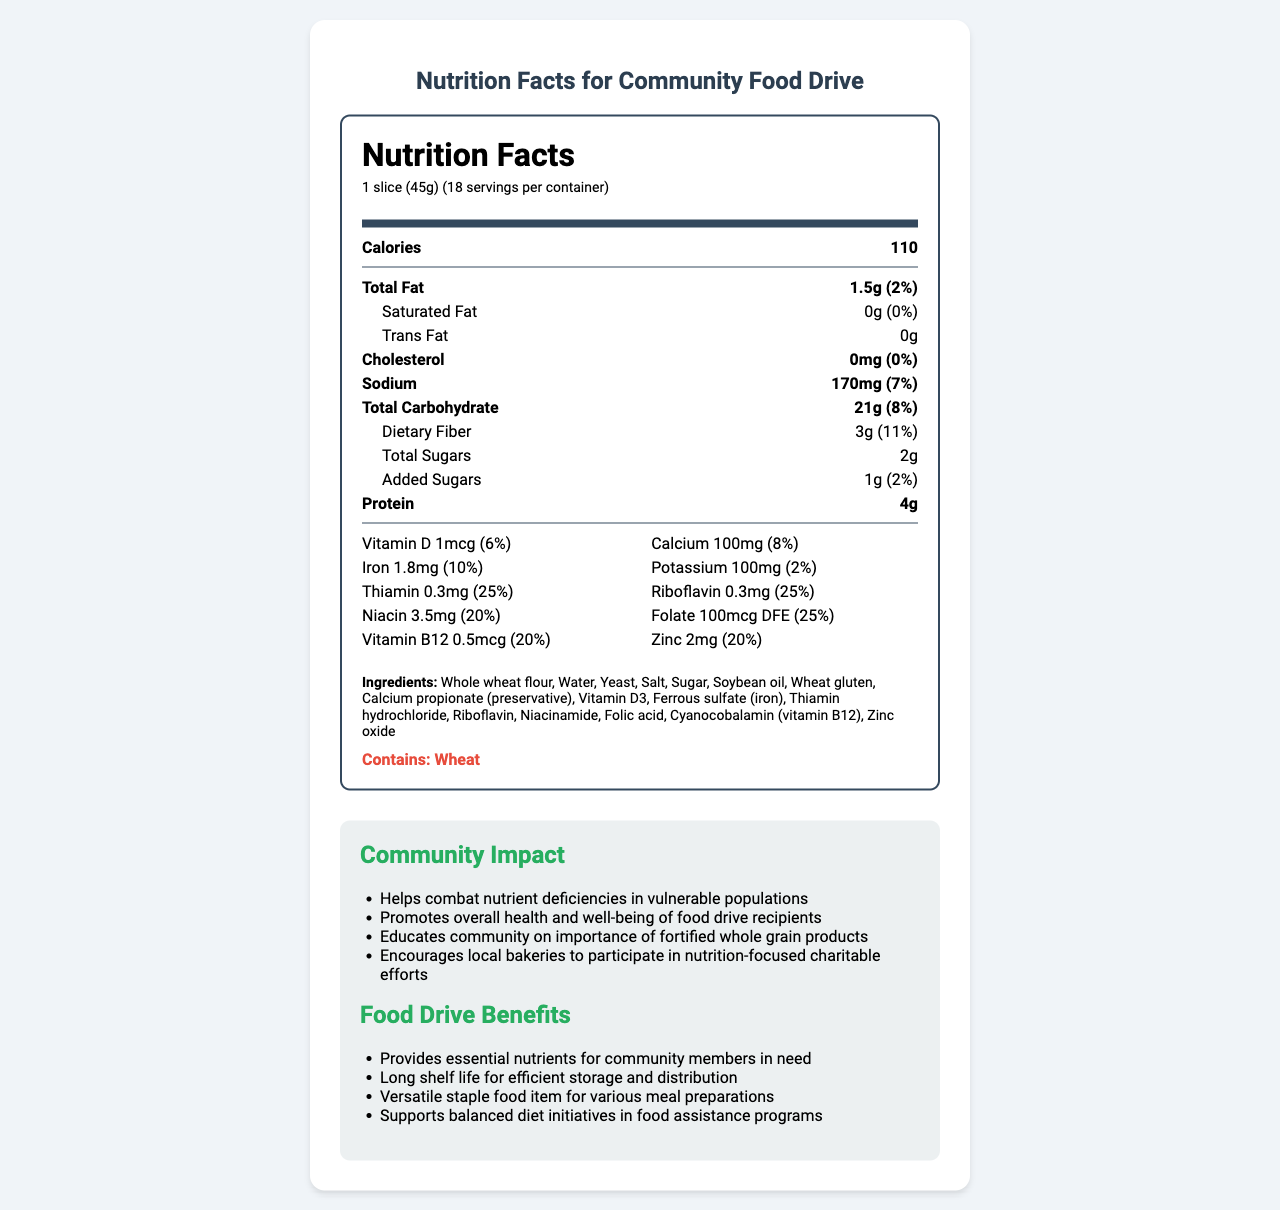what is the serving size? The serving size is listed as "1 slice (45g)".
Answer: 1 slice (45g) how many calories are there per serving? The calories per serving are specified as 110 calories.
Answer: 110 what is the total carbohydrate content per serving? The total carbohydrate content per serving is listed as 21g.
Answer: 21g how much iron is in one serving, and what percentage of the daily value does it represent? The iron content per serving is 1.8mg, which represents 10% of the daily value.
Answer: 1.8mg, 10% what vitamins are fortified in the bread, and what are their daily values? The vitamins fortified in the bread and their daily values are: Vitamin D (6%), Thiamin (25%), Riboflavin (25%), Niacin (20%), Folate (25%), Vitamin B12 (20%).
Answer: Vitamin D (6%), Thiamin (25%), Riboflavin (25%), Niacin (20%), Folate (25%), Vitamin B12 (20%) what are the allergens present in this bread? The allergen information states that the bread contains wheat.
Answer: Wheat which of the following nutrients does the bread provide 25% of the daily value? A. Vitamin D B. Vitamin B12 C. Thiamin D. Iron Thiamin provides 25% of the daily value, which is listed in the document.
Answer: C. Thiamin how many grams of dietary fiber are there per serving? The dietary fiber content per serving is listed as 3g.
Answer: 3g how much sodium does one slice contain, and what is its percentage of daily value? One slice contains 170mg of sodium, which represents 7% of the daily value.
Answer: 170mg, 7% is there any trans fat in this bread? The trans fat content is listed as 0g, indicating there is no trans fat in this bread.
Answer: No how does the bread benefit the community food drive? (choose all that apply) I. Provides essential nutrients for community members in need II. Long shelf life for efficient storage and distribution III. Versatile staple food item for various meal preparations IV. Contains no sugars V. Supports balanced diet initiatives in food assistance programs The benefits listed are: I. Provides essential nutrients for community members in need, II. Long shelf life for efficient storage and distribution, III. Versatile staple food item for various meal preparations, V. Supports balanced diet initiatives in food assistance programs.
Answer: I, II, III, V how many servings are there per container? The document states that there are 18 servings per container.
Answer: 18 what is the main idea of the document? The document is a comprehensive presentation of the nutritional aspects of Community Harvest Fortified Whole Grain Bread, its ingredients, and how it benefits the community, especially in a food drive context.
Answer: The document provides detailed nutritional information about Community Harvest Fortified Whole Grain Bread, emphasizing its vitamin and mineral content, ingredients, allergen information, and the benefits for the community food drive. does the bread contain calcium? The document lists that one serving contains 100mg of calcium, which is 8% of the daily value.
Answer: Yes what are the community impacts of distributing this bread through the food drive? The community impact section lists these specific benefits: Helps combat nutrient deficiencies in vulnerable populations, promotes overall health and well-being of food drive recipients, educates the community on the importance of fortified whole grain products, and encourages local bakeries to participate in nutrition-focused charitable efforts.
Answer: Helps combat nutrient deficiencies in vulnerable populations, promotes overall health and well-being of food drive recipients, educates community on the importance of fortified whole grain products, encourages local bakeries to participate in nutrition-focused charitable efforts how long can the bread be stored for distribution within the community food drive? The document does not specify the exact shelf life duration, only stating that it has a "long shelf life for efficient storage and distribution."
Answer: Not enough information 